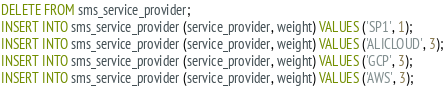Convert code to text. <code><loc_0><loc_0><loc_500><loc_500><_SQL_>DELETE FROM sms_service_provider;
INSERT INTO sms_service_provider (service_provider, weight) VALUES ('SP1', 1);
INSERT INTO sms_service_provider (service_provider, weight) VALUES ('ALICLOUD', 3);
INSERT INTO sms_service_provider (service_provider, weight) VALUES ('GCP', 3);
INSERT INTO sms_service_provider (service_provider, weight) VALUES ('AWS', 3);
</code> 